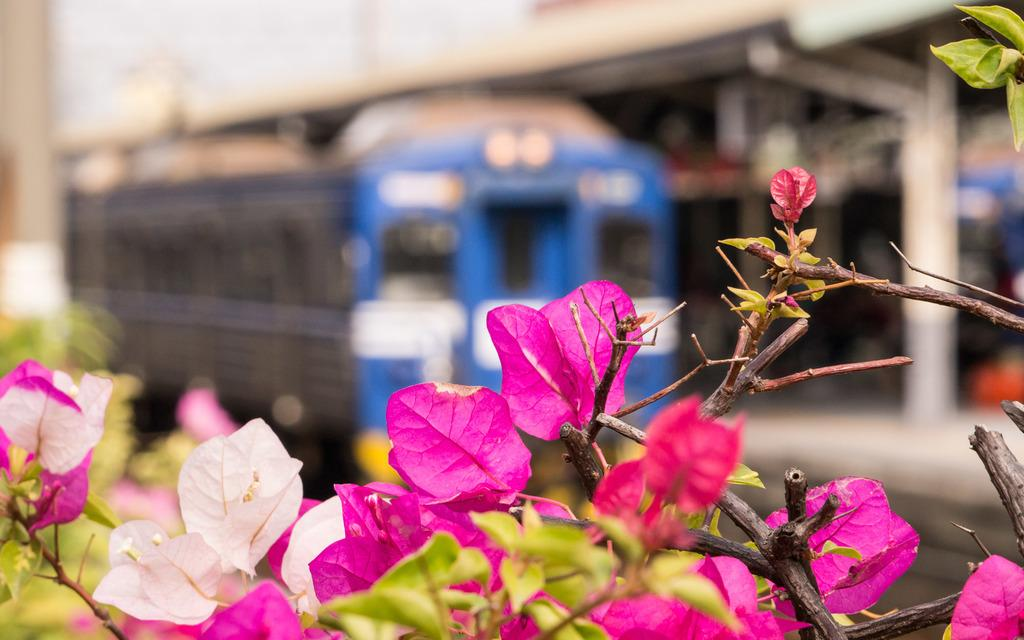What colors of flowers can be seen in the image? There are pink, white, and red flowers in the image. What other elements can be seen in the image besides flowers? There are green leaves in the image. How would you describe the background of the image? The background of the image is blurred. What type of adjustment can be made to the oven in the image? There is no oven present in the image, so no adjustments can be made to it. 